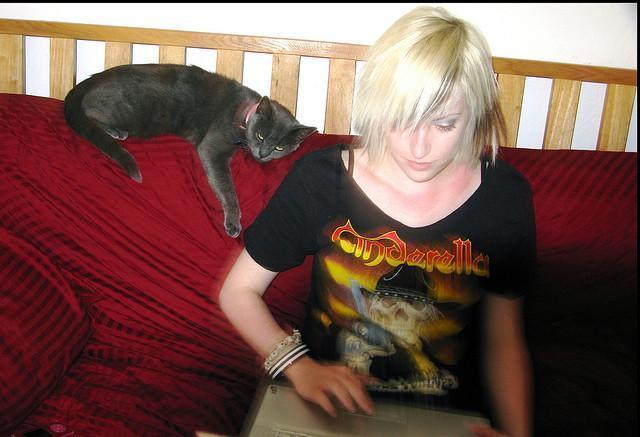What type of furniture is the girl sitting on?
Choose the correct response, then elucidate: 'Answer: answer
Rationale: rationale.'
Options: Futon, recliner, chaise, sectional. Answer: futon.
Rationale: The girl is sitting on a futon which is made of a wooden frame and a thin mat. 